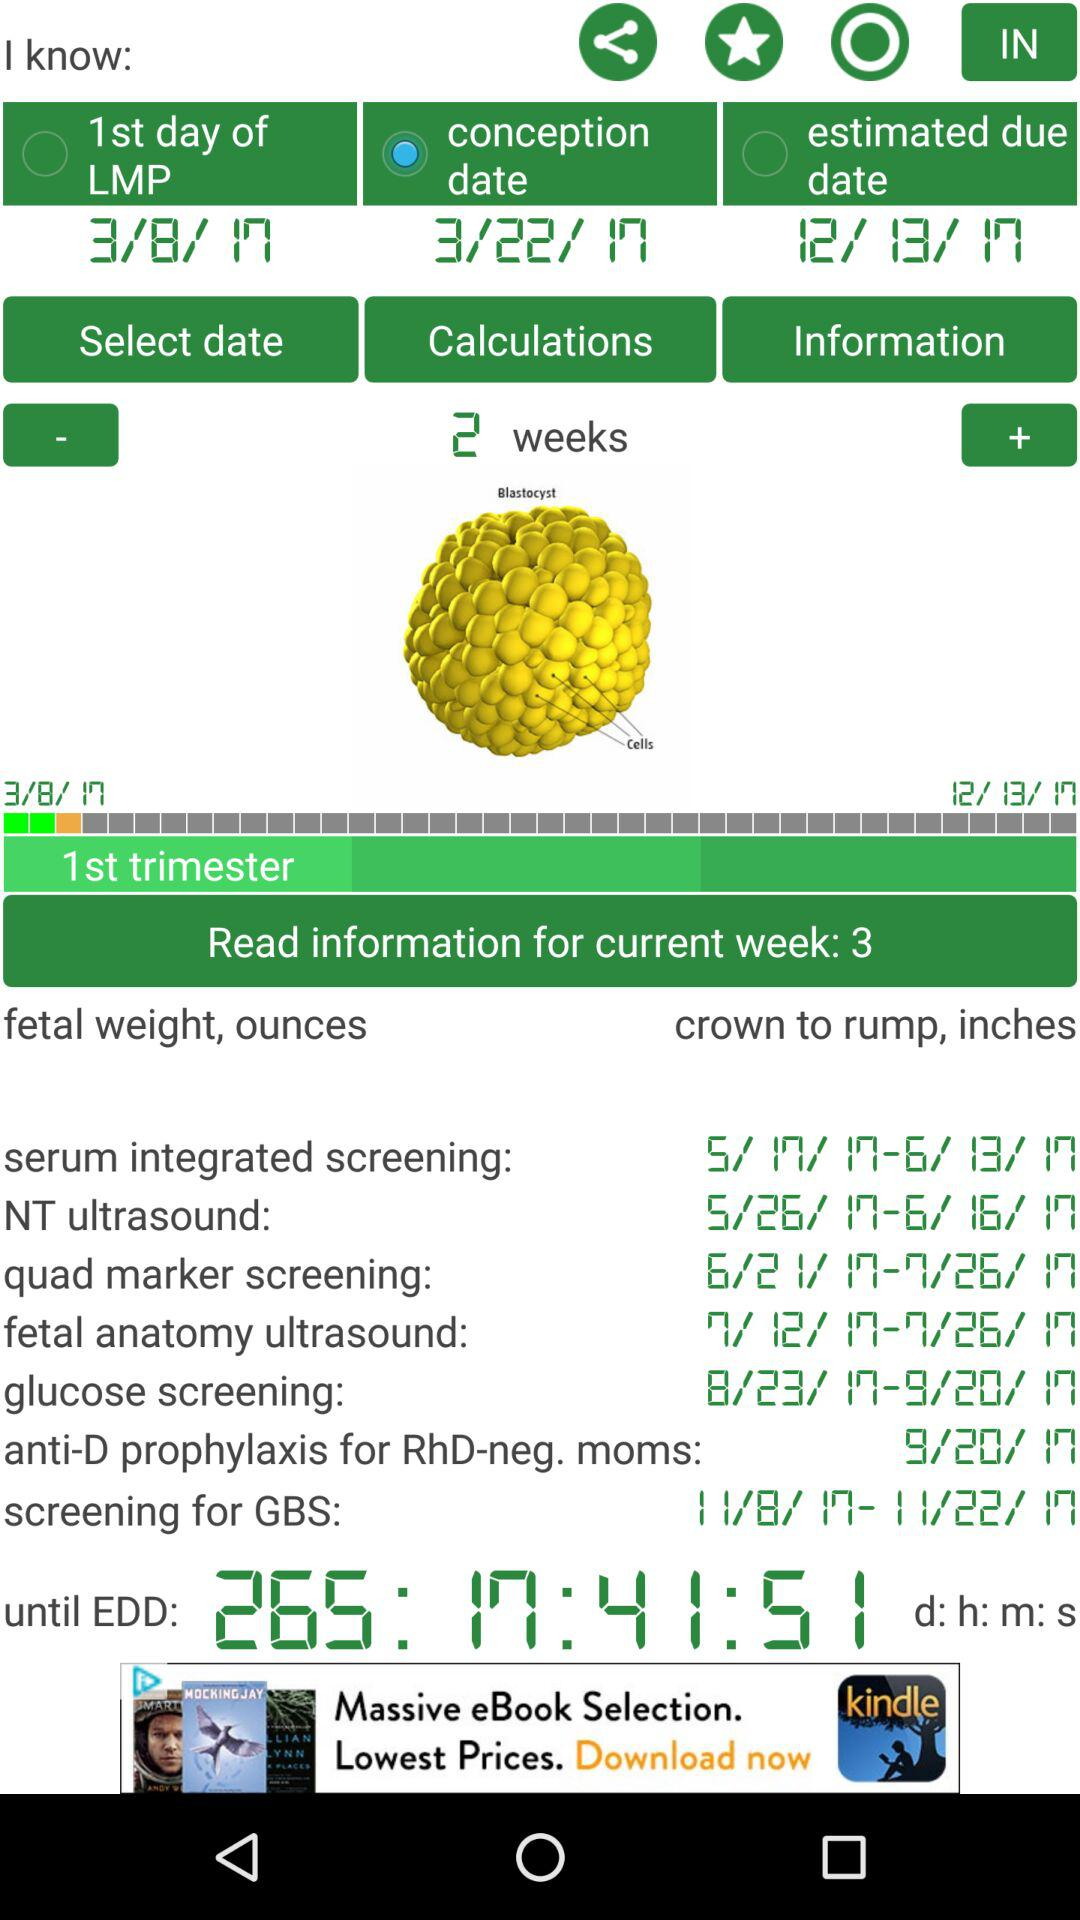What week is currently going on? It is the third week that is currently going on. 